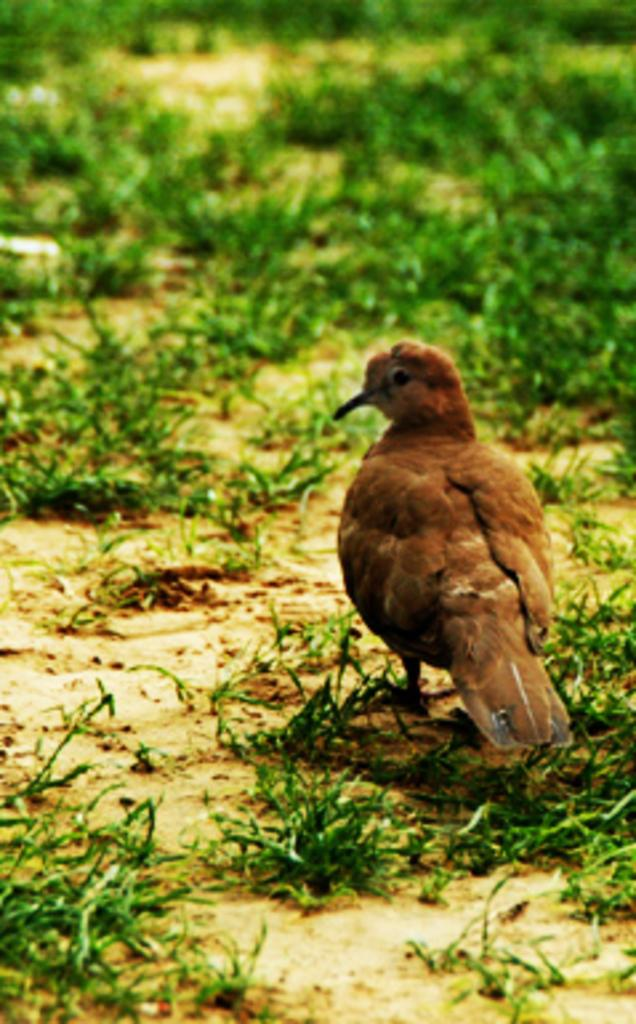What type of animal can be seen in the image? There is a bird in the image. Where is the bird located in the image? The bird is on the ground. What type of vegetation is visible in the image? There is grass visible in the image. What type of structure can be seen in the background of the image? There is no structure visible in the image; it only shows a bird on the ground and grass. 